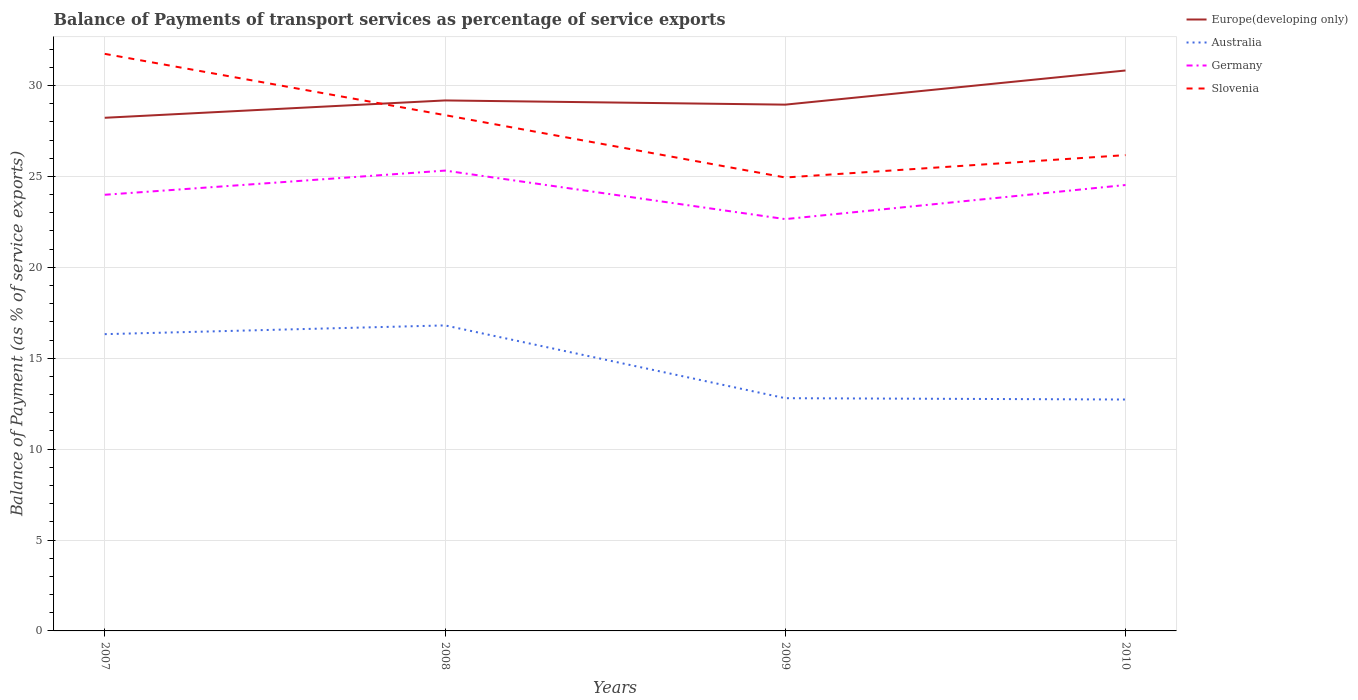Does the line corresponding to Slovenia intersect with the line corresponding to Europe(developing only)?
Offer a terse response. Yes. Across all years, what is the maximum balance of payments of transport services in Germany?
Offer a very short reply. 22.65. In which year was the balance of payments of transport services in Europe(developing only) maximum?
Keep it short and to the point. 2007. What is the total balance of payments of transport services in Germany in the graph?
Give a very brief answer. 0.79. What is the difference between the highest and the second highest balance of payments of transport services in Australia?
Your answer should be very brief. 4.08. What is the difference between the highest and the lowest balance of payments of transport services in Germany?
Your answer should be very brief. 2. Are the values on the major ticks of Y-axis written in scientific E-notation?
Give a very brief answer. No. Does the graph contain any zero values?
Your answer should be compact. No. Does the graph contain grids?
Provide a short and direct response. Yes. How many legend labels are there?
Provide a short and direct response. 4. How are the legend labels stacked?
Give a very brief answer. Vertical. What is the title of the graph?
Keep it short and to the point. Balance of Payments of transport services as percentage of service exports. What is the label or title of the Y-axis?
Ensure brevity in your answer.  Balance of Payment (as % of service exports). What is the Balance of Payment (as % of service exports) of Europe(developing only) in 2007?
Keep it short and to the point. 28.23. What is the Balance of Payment (as % of service exports) in Australia in 2007?
Make the answer very short. 16.32. What is the Balance of Payment (as % of service exports) in Germany in 2007?
Your answer should be compact. 23.99. What is the Balance of Payment (as % of service exports) in Slovenia in 2007?
Offer a terse response. 31.74. What is the Balance of Payment (as % of service exports) in Europe(developing only) in 2008?
Provide a short and direct response. 29.18. What is the Balance of Payment (as % of service exports) of Australia in 2008?
Your answer should be compact. 16.81. What is the Balance of Payment (as % of service exports) in Germany in 2008?
Your answer should be very brief. 25.32. What is the Balance of Payment (as % of service exports) in Slovenia in 2008?
Make the answer very short. 28.37. What is the Balance of Payment (as % of service exports) of Europe(developing only) in 2009?
Offer a terse response. 28.95. What is the Balance of Payment (as % of service exports) in Australia in 2009?
Offer a terse response. 12.8. What is the Balance of Payment (as % of service exports) of Germany in 2009?
Your response must be concise. 22.65. What is the Balance of Payment (as % of service exports) of Slovenia in 2009?
Your answer should be very brief. 24.94. What is the Balance of Payment (as % of service exports) in Europe(developing only) in 2010?
Make the answer very short. 30.83. What is the Balance of Payment (as % of service exports) of Australia in 2010?
Provide a succinct answer. 12.73. What is the Balance of Payment (as % of service exports) in Germany in 2010?
Keep it short and to the point. 24.53. What is the Balance of Payment (as % of service exports) of Slovenia in 2010?
Your response must be concise. 26.17. Across all years, what is the maximum Balance of Payment (as % of service exports) in Europe(developing only)?
Your answer should be compact. 30.83. Across all years, what is the maximum Balance of Payment (as % of service exports) of Australia?
Offer a terse response. 16.81. Across all years, what is the maximum Balance of Payment (as % of service exports) of Germany?
Ensure brevity in your answer.  25.32. Across all years, what is the maximum Balance of Payment (as % of service exports) in Slovenia?
Give a very brief answer. 31.74. Across all years, what is the minimum Balance of Payment (as % of service exports) of Europe(developing only)?
Provide a succinct answer. 28.23. Across all years, what is the minimum Balance of Payment (as % of service exports) of Australia?
Provide a short and direct response. 12.73. Across all years, what is the minimum Balance of Payment (as % of service exports) of Germany?
Your answer should be compact. 22.65. Across all years, what is the minimum Balance of Payment (as % of service exports) in Slovenia?
Offer a terse response. 24.94. What is the total Balance of Payment (as % of service exports) in Europe(developing only) in the graph?
Keep it short and to the point. 117.18. What is the total Balance of Payment (as % of service exports) in Australia in the graph?
Your answer should be very brief. 58.66. What is the total Balance of Payment (as % of service exports) in Germany in the graph?
Your answer should be compact. 96.49. What is the total Balance of Payment (as % of service exports) of Slovenia in the graph?
Keep it short and to the point. 111.23. What is the difference between the Balance of Payment (as % of service exports) of Europe(developing only) in 2007 and that in 2008?
Provide a short and direct response. -0.95. What is the difference between the Balance of Payment (as % of service exports) in Australia in 2007 and that in 2008?
Your answer should be very brief. -0.48. What is the difference between the Balance of Payment (as % of service exports) in Germany in 2007 and that in 2008?
Provide a short and direct response. -1.33. What is the difference between the Balance of Payment (as % of service exports) in Slovenia in 2007 and that in 2008?
Your response must be concise. 3.37. What is the difference between the Balance of Payment (as % of service exports) in Europe(developing only) in 2007 and that in 2009?
Provide a short and direct response. -0.72. What is the difference between the Balance of Payment (as % of service exports) of Australia in 2007 and that in 2009?
Your response must be concise. 3.52. What is the difference between the Balance of Payment (as % of service exports) of Germany in 2007 and that in 2009?
Make the answer very short. 1.34. What is the difference between the Balance of Payment (as % of service exports) in Slovenia in 2007 and that in 2009?
Your answer should be very brief. 6.8. What is the difference between the Balance of Payment (as % of service exports) in Europe(developing only) in 2007 and that in 2010?
Provide a succinct answer. -2.6. What is the difference between the Balance of Payment (as % of service exports) in Australia in 2007 and that in 2010?
Ensure brevity in your answer.  3.6. What is the difference between the Balance of Payment (as % of service exports) in Germany in 2007 and that in 2010?
Ensure brevity in your answer.  -0.54. What is the difference between the Balance of Payment (as % of service exports) of Slovenia in 2007 and that in 2010?
Ensure brevity in your answer.  5.57. What is the difference between the Balance of Payment (as % of service exports) of Europe(developing only) in 2008 and that in 2009?
Keep it short and to the point. 0.23. What is the difference between the Balance of Payment (as % of service exports) in Australia in 2008 and that in 2009?
Your answer should be compact. 4. What is the difference between the Balance of Payment (as % of service exports) of Germany in 2008 and that in 2009?
Ensure brevity in your answer.  2.67. What is the difference between the Balance of Payment (as % of service exports) of Slovenia in 2008 and that in 2009?
Offer a very short reply. 3.43. What is the difference between the Balance of Payment (as % of service exports) of Europe(developing only) in 2008 and that in 2010?
Your answer should be very brief. -1.65. What is the difference between the Balance of Payment (as % of service exports) of Australia in 2008 and that in 2010?
Keep it short and to the point. 4.08. What is the difference between the Balance of Payment (as % of service exports) in Germany in 2008 and that in 2010?
Your answer should be compact. 0.79. What is the difference between the Balance of Payment (as % of service exports) of Slovenia in 2008 and that in 2010?
Provide a short and direct response. 2.2. What is the difference between the Balance of Payment (as % of service exports) of Europe(developing only) in 2009 and that in 2010?
Offer a terse response. -1.88. What is the difference between the Balance of Payment (as % of service exports) in Australia in 2009 and that in 2010?
Ensure brevity in your answer.  0.07. What is the difference between the Balance of Payment (as % of service exports) of Germany in 2009 and that in 2010?
Offer a very short reply. -1.88. What is the difference between the Balance of Payment (as % of service exports) of Slovenia in 2009 and that in 2010?
Make the answer very short. -1.23. What is the difference between the Balance of Payment (as % of service exports) in Europe(developing only) in 2007 and the Balance of Payment (as % of service exports) in Australia in 2008?
Ensure brevity in your answer.  11.42. What is the difference between the Balance of Payment (as % of service exports) of Europe(developing only) in 2007 and the Balance of Payment (as % of service exports) of Germany in 2008?
Offer a very short reply. 2.9. What is the difference between the Balance of Payment (as % of service exports) in Europe(developing only) in 2007 and the Balance of Payment (as % of service exports) in Slovenia in 2008?
Offer a terse response. -0.15. What is the difference between the Balance of Payment (as % of service exports) in Australia in 2007 and the Balance of Payment (as % of service exports) in Germany in 2008?
Keep it short and to the point. -9. What is the difference between the Balance of Payment (as % of service exports) of Australia in 2007 and the Balance of Payment (as % of service exports) of Slovenia in 2008?
Give a very brief answer. -12.05. What is the difference between the Balance of Payment (as % of service exports) of Germany in 2007 and the Balance of Payment (as % of service exports) of Slovenia in 2008?
Offer a very short reply. -4.38. What is the difference between the Balance of Payment (as % of service exports) of Europe(developing only) in 2007 and the Balance of Payment (as % of service exports) of Australia in 2009?
Offer a very short reply. 15.42. What is the difference between the Balance of Payment (as % of service exports) of Europe(developing only) in 2007 and the Balance of Payment (as % of service exports) of Germany in 2009?
Make the answer very short. 5.57. What is the difference between the Balance of Payment (as % of service exports) in Europe(developing only) in 2007 and the Balance of Payment (as % of service exports) in Slovenia in 2009?
Provide a succinct answer. 3.28. What is the difference between the Balance of Payment (as % of service exports) in Australia in 2007 and the Balance of Payment (as % of service exports) in Germany in 2009?
Provide a succinct answer. -6.33. What is the difference between the Balance of Payment (as % of service exports) of Australia in 2007 and the Balance of Payment (as % of service exports) of Slovenia in 2009?
Ensure brevity in your answer.  -8.62. What is the difference between the Balance of Payment (as % of service exports) in Germany in 2007 and the Balance of Payment (as % of service exports) in Slovenia in 2009?
Your answer should be compact. -0.95. What is the difference between the Balance of Payment (as % of service exports) in Europe(developing only) in 2007 and the Balance of Payment (as % of service exports) in Australia in 2010?
Make the answer very short. 15.5. What is the difference between the Balance of Payment (as % of service exports) in Europe(developing only) in 2007 and the Balance of Payment (as % of service exports) in Germany in 2010?
Give a very brief answer. 3.7. What is the difference between the Balance of Payment (as % of service exports) of Europe(developing only) in 2007 and the Balance of Payment (as % of service exports) of Slovenia in 2010?
Provide a succinct answer. 2.05. What is the difference between the Balance of Payment (as % of service exports) of Australia in 2007 and the Balance of Payment (as % of service exports) of Germany in 2010?
Keep it short and to the point. -8.2. What is the difference between the Balance of Payment (as % of service exports) of Australia in 2007 and the Balance of Payment (as % of service exports) of Slovenia in 2010?
Ensure brevity in your answer.  -9.85. What is the difference between the Balance of Payment (as % of service exports) in Germany in 2007 and the Balance of Payment (as % of service exports) in Slovenia in 2010?
Give a very brief answer. -2.18. What is the difference between the Balance of Payment (as % of service exports) of Europe(developing only) in 2008 and the Balance of Payment (as % of service exports) of Australia in 2009?
Provide a succinct answer. 16.38. What is the difference between the Balance of Payment (as % of service exports) of Europe(developing only) in 2008 and the Balance of Payment (as % of service exports) of Germany in 2009?
Keep it short and to the point. 6.53. What is the difference between the Balance of Payment (as % of service exports) of Europe(developing only) in 2008 and the Balance of Payment (as % of service exports) of Slovenia in 2009?
Ensure brevity in your answer.  4.24. What is the difference between the Balance of Payment (as % of service exports) in Australia in 2008 and the Balance of Payment (as % of service exports) in Germany in 2009?
Offer a very short reply. -5.85. What is the difference between the Balance of Payment (as % of service exports) in Australia in 2008 and the Balance of Payment (as % of service exports) in Slovenia in 2009?
Your response must be concise. -8.14. What is the difference between the Balance of Payment (as % of service exports) in Germany in 2008 and the Balance of Payment (as % of service exports) in Slovenia in 2009?
Your answer should be very brief. 0.38. What is the difference between the Balance of Payment (as % of service exports) of Europe(developing only) in 2008 and the Balance of Payment (as % of service exports) of Australia in 2010?
Keep it short and to the point. 16.45. What is the difference between the Balance of Payment (as % of service exports) of Europe(developing only) in 2008 and the Balance of Payment (as % of service exports) of Germany in 2010?
Keep it short and to the point. 4.65. What is the difference between the Balance of Payment (as % of service exports) in Europe(developing only) in 2008 and the Balance of Payment (as % of service exports) in Slovenia in 2010?
Ensure brevity in your answer.  3.01. What is the difference between the Balance of Payment (as % of service exports) in Australia in 2008 and the Balance of Payment (as % of service exports) in Germany in 2010?
Your response must be concise. -7.72. What is the difference between the Balance of Payment (as % of service exports) in Australia in 2008 and the Balance of Payment (as % of service exports) in Slovenia in 2010?
Provide a succinct answer. -9.37. What is the difference between the Balance of Payment (as % of service exports) in Germany in 2008 and the Balance of Payment (as % of service exports) in Slovenia in 2010?
Ensure brevity in your answer.  -0.85. What is the difference between the Balance of Payment (as % of service exports) in Europe(developing only) in 2009 and the Balance of Payment (as % of service exports) in Australia in 2010?
Keep it short and to the point. 16.22. What is the difference between the Balance of Payment (as % of service exports) in Europe(developing only) in 2009 and the Balance of Payment (as % of service exports) in Germany in 2010?
Offer a terse response. 4.42. What is the difference between the Balance of Payment (as % of service exports) in Europe(developing only) in 2009 and the Balance of Payment (as % of service exports) in Slovenia in 2010?
Your answer should be very brief. 2.78. What is the difference between the Balance of Payment (as % of service exports) in Australia in 2009 and the Balance of Payment (as % of service exports) in Germany in 2010?
Provide a succinct answer. -11.73. What is the difference between the Balance of Payment (as % of service exports) in Australia in 2009 and the Balance of Payment (as % of service exports) in Slovenia in 2010?
Ensure brevity in your answer.  -13.37. What is the difference between the Balance of Payment (as % of service exports) of Germany in 2009 and the Balance of Payment (as % of service exports) of Slovenia in 2010?
Ensure brevity in your answer.  -3.52. What is the average Balance of Payment (as % of service exports) of Europe(developing only) per year?
Offer a very short reply. 29.29. What is the average Balance of Payment (as % of service exports) of Australia per year?
Offer a terse response. 14.66. What is the average Balance of Payment (as % of service exports) in Germany per year?
Keep it short and to the point. 24.12. What is the average Balance of Payment (as % of service exports) of Slovenia per year?
Your answer should be compact. 27.81. In the year 2007, what is the difference between the Balance of Payment (as % of service exports) of Europe(developing only) and Balance of Payment (as % of service exports) of Australia?
Your answer should be very brief. 11.9. In the year 2007, what is the difference between the Balance of Payment (as % of service exports) in Europe(developing only) and Balance of Payment (as % of service exports) in Germany?
Ensure brevity in your answer.  4.23. In the year 2007, what is the difference between the Balance of Payment (as % of service exports) of Europe(developing only) and Balance of Payment (as % of service exports) of Slovenia?
Provide a succinct answer. -3.52. In the year 2007, what is the difference between the Balance of Payment (as % of service exports) in Australia and Balance of Payment (as % of service exports) in Germany?
Your response must be concise. -7.67. In the year 2007, what is the difference between the Balance of Payment (as % of service exports) of Australia and Balance of Payment (as % of service exports) of Slovenia?
Keep it short and to the point. -15.42. In the year 2007, what is the difference between the Balance of Payment (as % of service exports) in Germany and Balance of Payment (as % of service exports) in Slovenia?
Make the answer very short. -7.75. In the year 2008, what is the difference between the Balance of Payment (as % of service exports) of Europe(developing only) and Balance of Payment (as % of service exports) of Australia?
Provide a short and direct response. 12.37. In the year 2008, what is the difference between the Balance of Payment (as % of service exports) of Europe(developing only) and Balance of Payment (as % of service exports) of Germany?
Offer a very short reply. 3.86. In the year 2008, what is the difference between the Balance of Payment (as % of service exports) of Europe(developing only) and Balance of Payment (as % of service exports) of Slovenia?
Provide a short and direct response. 0.81. In the year 2008, what is the difference between the Balance of Payment (as % of service exports) in Australia and Balance of Payment (as % of service exports) in Germany?
Keep it short and to the point. -8.52. In the year 2008, what is the difference between the Balance of Payment (as % of service exports) of Australia and Balance of Payment (as % of service exports) of Slovenia?
Your answer should be compact. -11.57. In the year 2008, what is the difference between the Balance of Payment (as % of service exports) in Germany and Balance of Payment (as % of service exports) in Slovenia?
Your answer should be compact. -3.05. In the year 2009, what is the difference between the Balance of Payment (as % of service exports) in Europe(developing only) and Balance of Payment (as % of service exports) in Australia?
Give a very brief answer. 16.15. In the year 2009, what is the difference between the Balance of Payment (as % of service exports) in Europe(developing only) and Balance of Payment (as % of service exports) in Germany?
Make the answer very short. 6.3. In the year 2009, what is the difference between the Balance of Payment (as % of service exports) in Europe(developing only) and Balance of Payment (as % of service exports) in Slovenia?
Keep it short and to the point. 4.01. In the year 2009, what is the difference between the Balance of Payment (as % of service exports) of Australia and Balance of Payment (as % of service exports) of Germany?
Give a very brief answer. -9.85. In the year 2009, what is the difference between the Balance of Payment (as % of service exports) in Australia and Balance of Payment (as % of service exports) in Slovenia?
Keep it short and to the point. -12.14. In the year 2009, what is the difference between the Balance of Payment (as % of service exports) in Germany and Balance of Payment (as % of service exports) in Slovenia?
Ensure brevity in your answer.  -2.29. In the year 2010, what is the difference between the Balance of Payment (as % of service exports) of Europe(developing only) and Balance of Payment (as % of service exports) of Australia?
Your answer should be very brief. 18.1. In the year 2010, what is the difference between the Balance of Payment (as % of service exports) in Europe(developing only) and Balance of Payment (as % of service exports) in Germany?
Your answer should be compact. 6.3. In the year 2010, what is the difference between the Balance of Payment (as % of service exports) of Europe(developing only) and Balance of Payment (as % of service exports) of Slovenia?
Provide a succinct answer. 4.65. In the year 2010, what is the difference between the Balance of Payment (as % of service exports) in Australia and Balance of Payment (as % of service exports) in Germany?
Your answer should be very brief. -11.8. In the year 2010, what is the difference between the Balance of Payment (as % of service exports) in Australia and Balance of Payment (as % of service exports) in Slovenia?
Your response must be concise. -13.44. In the year 2010, what is the difference between the Balance of Payment (as % of service exports) in Germany and Balance of Payment (as % of service exports) in Slovenia?
Offer a terse response. -1.64. What is the ratio of the Balance of Payment (as % of service exports) of Europe(developing only) in 2007 to that in 2008?
Ensure brevity in your answer.  0.97. What is the ratio of the Balance of Payment (as % of service exports) of Australia in 2007 to that in 2008?
Your response must be concise. 0.97. What is the ratio of the Balance of Payment (as % of service exports) in Germany in 2007 to that in 2008?
Ensure brevity in your answer.  0.95. What is the ratio of the Balance of Payment (as % of service exports) of Slovenia in 2007 to that in 2008?
Offer a terse response. 1.12. What is the ratio of the Balance of Payment (as % of service exports) of Australia in 2007 to that in 2009?
Your answer should be very brief. 1.28. What is the ratio of the Balance of Payment (as % of service exports) of Germany in 2007 to that in 2009?
Give a very brief answer. 1.06. What is the ratio of the Balance of Payment (as % of service exports) of Slovenia in 2007 to that in 2009?
Offer a very short reply. 1.27. What is the ratio of the Balance of Payment (as % of service exports) in Europe(developing only) in 2007 to that in 2010?
Offer a terse response. 0.92. What is the ratio of the Balance of Payment (as % of service exports) in Australia in 2007 to that in 2010?
Keep it short and to the point. 1.28. What is the ratio of the Balance of Payment (as % of service exports) in Germany in 2007 to that in 2010?
Your answer should be compact. 0.98. What is the ratio of the Balance of Payment (as % of service exports) of Slovenia in 2007 to that in 2010?
Keep it short and to the point. 1.21. What is the ratio of the Balance of Payment (as % of service exports) in Europe(developing only) in 2008 to that in 2009?
Keep it short and to the point. 1.01. What is the ratio of the Balance of Payment (as % of service exports) in Australia in 2008 to that in 2009?
Make the answer very short. 1.31. What is the ratio of the Balance of Payment (as % of service exports) in Germany in 2008 to that in 2009?
Your response must be concise. 1.12. What is the ratio of the Balance of Payment (as % of service exports) in Slovenia in 2008 to that in 2009?
Your answer should be compact. 1.14. What is the ratio of the Balance of Payment (as % of service exports) of Europe(developing only) in 2008 to that in 2010?
Offer a very short reply. 0.95. What is the ratio of the Balance of Payment (as % of service exports) of Australia in 2008 to that in 2010?
Ensure brevity in your answer.  1.32. What is the ratio of the Balance of Payment (as % of service exports) in Germany in 2008 to that in 2010?
Your answer should be compact. 1.03. What is the ratio of the Balance of Payment (as % of service exports) in Slovenia in 2008 to that in 2010?
Offer a very short reply. 1.08. What is the ratio of the Balance of Payment (as % of service exports) of Europe(developing only) in 2009 to that in 2010?
Ensure brevity in your answer.  0.94. What is the ratio of the Balance of Payment (as % of service exports) in Germany in 2009 to that in 2010?
Give a very brief answer. 0.92. What is the ratio of the Balance of Payment (as % of service exports) of Slovenia in 2009 to that in 2010?
Keep it short and to the point. 0.95. What is the difference between the highest and the second highest Balance of Payment (as % of service exports) of Europe(developing only)?
Your answer should be very brief. 1.65. What is the difference between the highest and the second highest Balance of Payment (as % of service exports) of Australia?
Keep it short and to the point. 0.48. What is the difference between the highest and the second highest Balance of Payment (as % of service exports) of Germany?
Provide a short and direct response. 0.79. What is the difference between the highest and the second highest Balance of Payment (as % of service exports) of Slovenia?
Offer a terse response. 3.37. What is the difference between the highest and the lowest Balance of Payment (as % of service exports) in Europe(developing only)?
Provide a succinct answer. 2.6. What is the difference between the highest and the lowest Balance of Payment (as % of service exports) of Australia?
Ensure brevity in your answer.  4.08. What is the difference between the highest and the lowest Balance of Payment (as % of service exports) in Germany?
Keep it short and to the point. 2.67. What is the difference between the highest and the lowest Balance of Payment (as % of service exports) in Slovenia?
Your response must be concise. 6.8. 